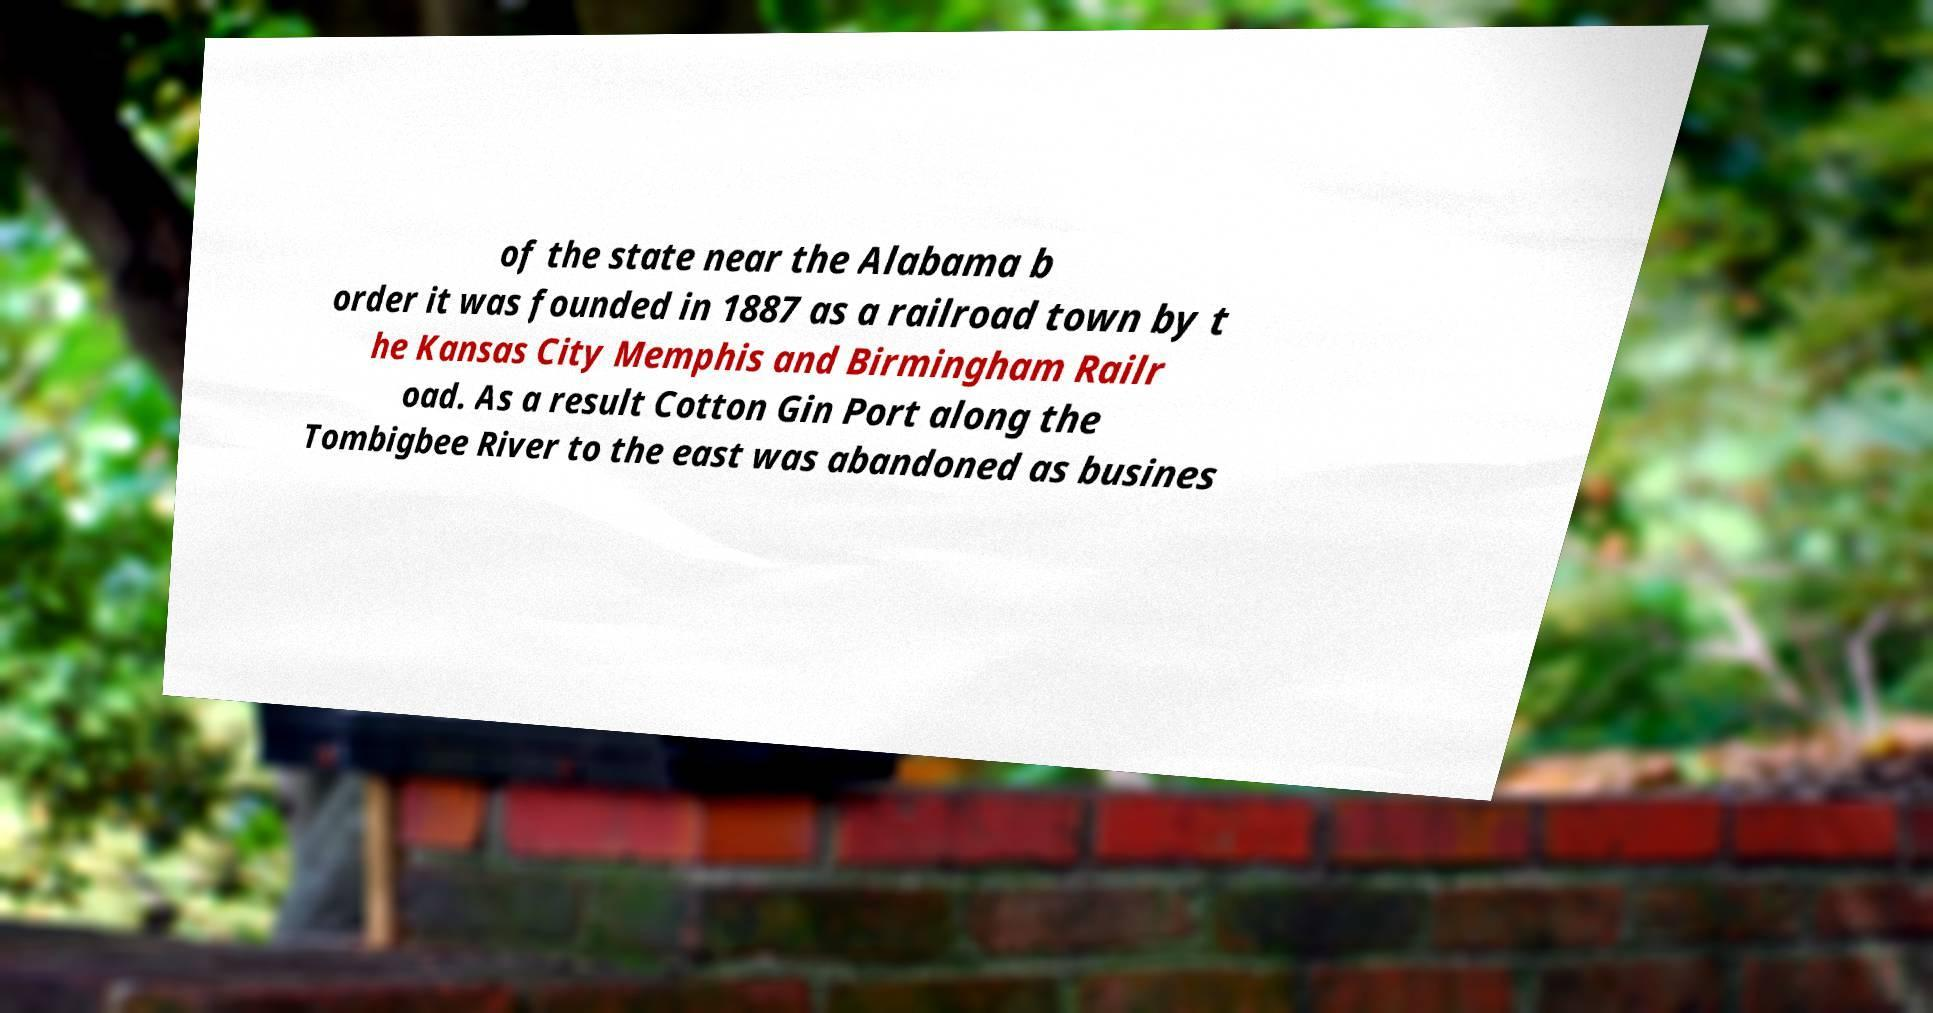Please read and relay the text visible in this image. What does it say? of the state near the Alabama b order it was founded in 1887 as a railroad town by t he Kansas City Memphis and Birmingham Railr oad. As a result Cotton Gin Port along the Tombigbee River to the east was abandoned as busines 